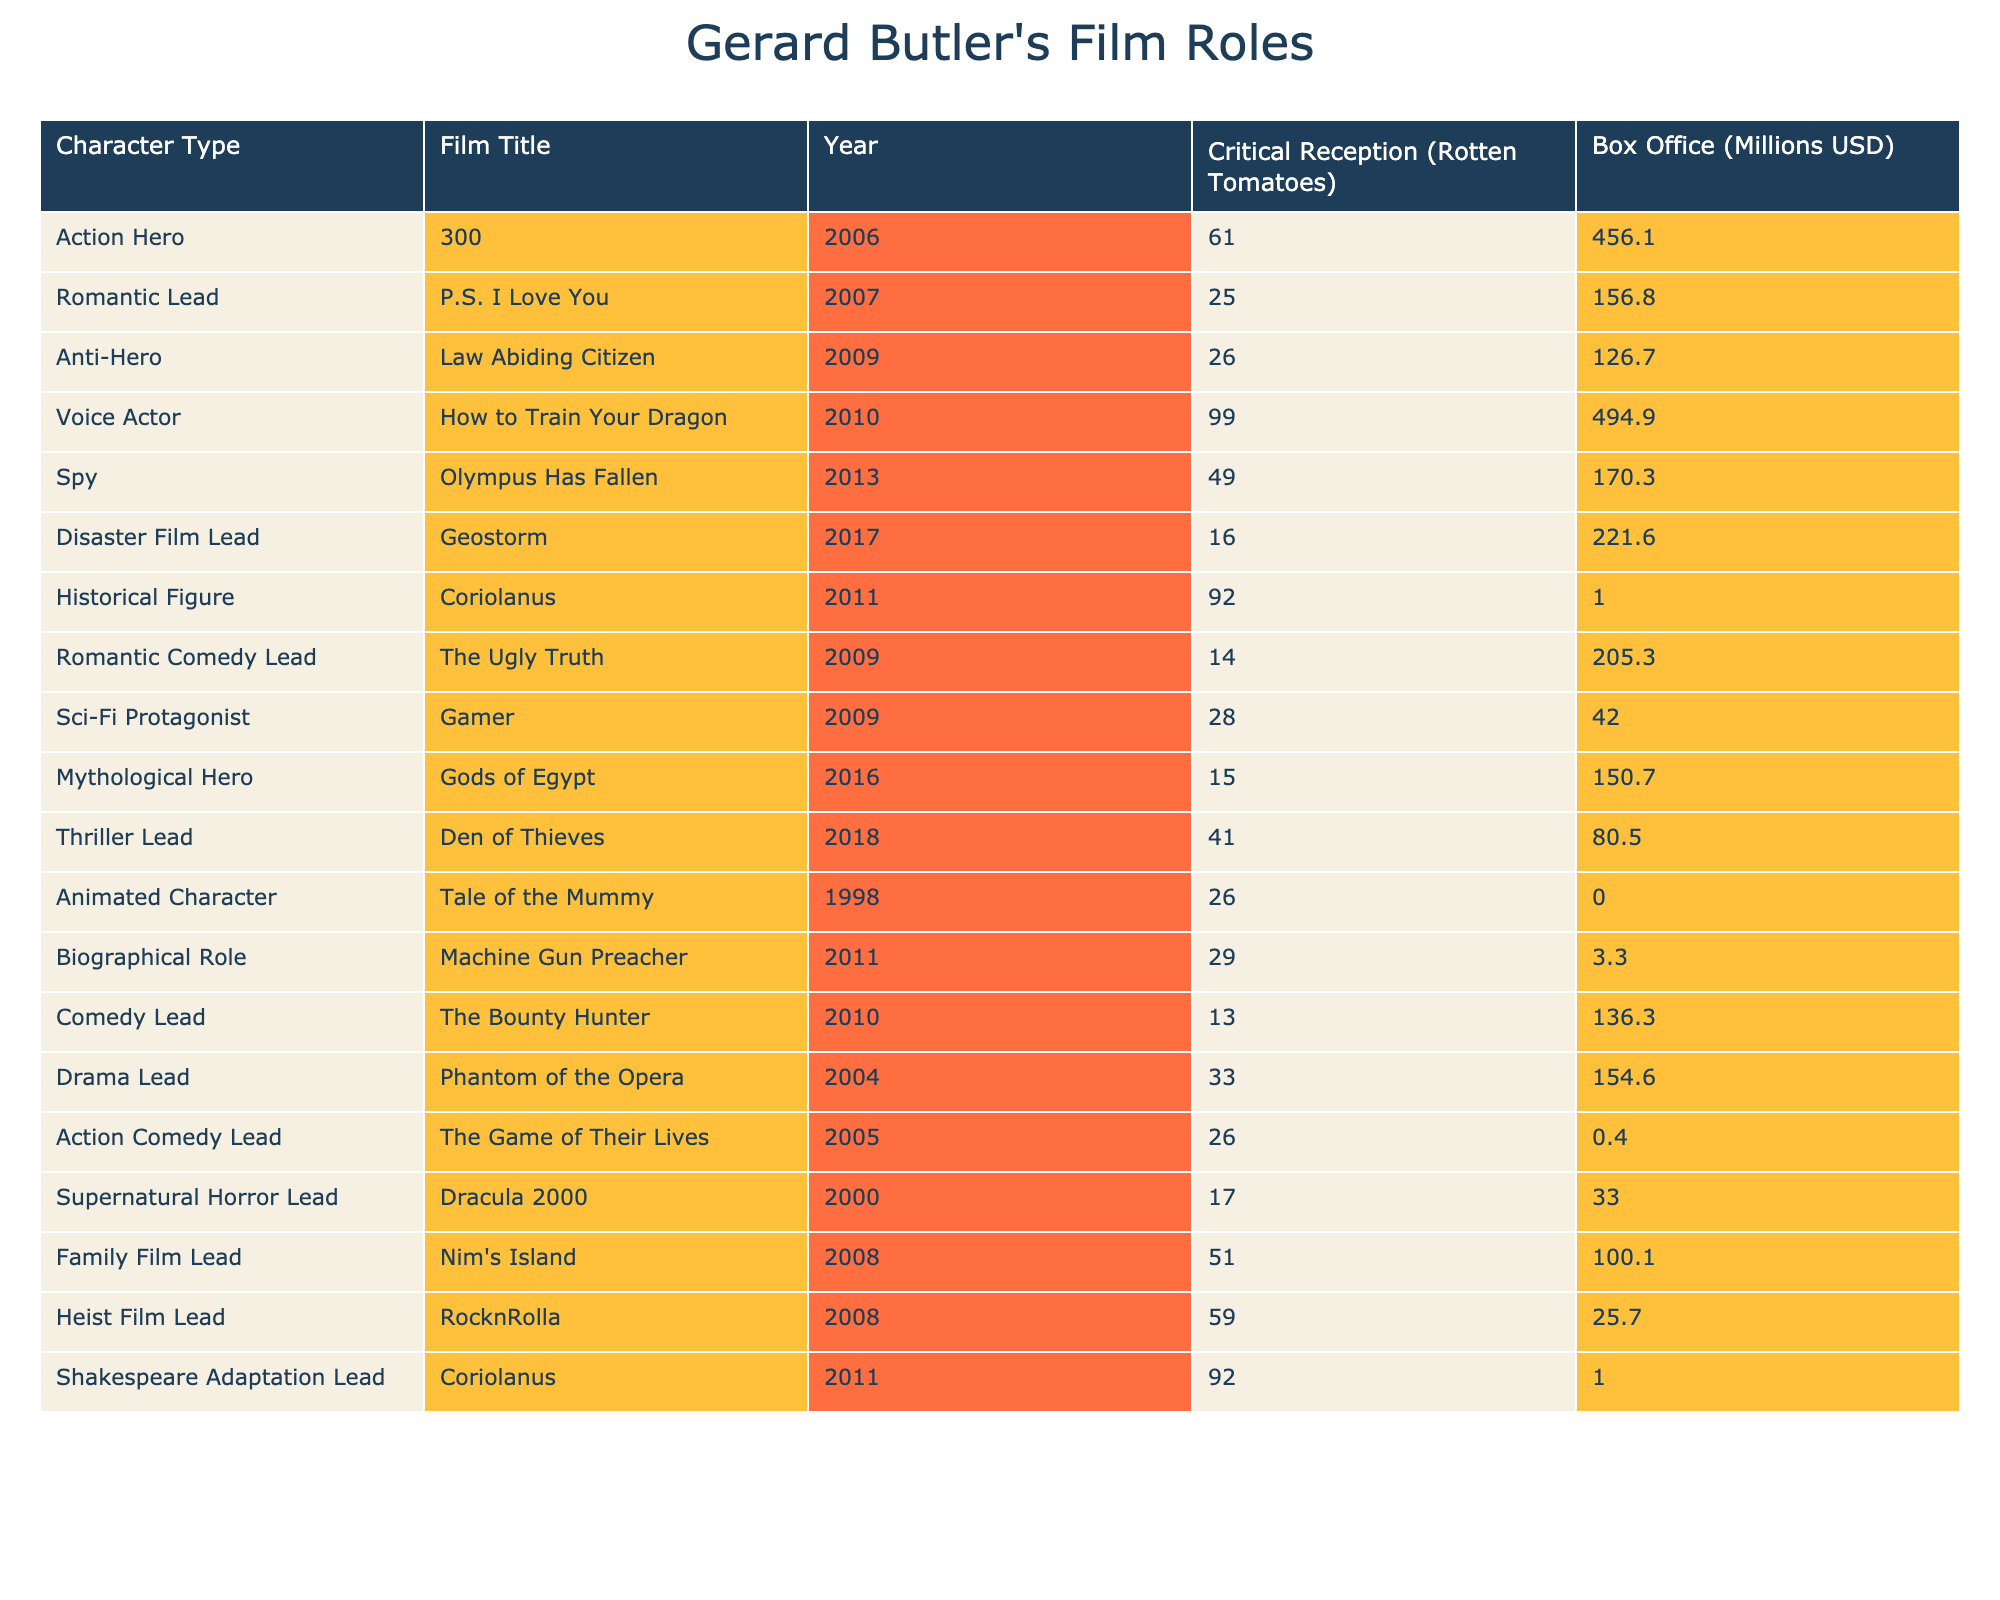What is the film with the highest critical reception among Gerard Butler's roles? Reviewing the table, "How to Train Your Dragon" has a critical reception score of 99%, which is the highest.
Answer: 99% Which film had the lowest box office earnings? Looking at the box office earnings, "Coriolanus" has the lowest earnings listed at 1 million USD.
Answer: 1 million USD What percentage of Gerard Butler's films received a critical reception above 50%? Out of 20 films, 7 films have critical reception scores above 50%: "How to Train Your Dragon," "Coriolanus," "Family Film Lead," "Heist Film Lead," and "300." Therefore, the percentage is (7/20) * 100 = 35%.
Answer: 35% Is "Geostorm" categorized as a disaster film lead? Yes, "Geostorm" is listed under the character type of Disaster Film Lead in the table.
Answer: Yes What is the average box office collection for the Action Hero roles? For the Action Hero role, the only entry is "300" with a box office of 456.1 million USD. Therefore, the average is simply 456.1 million USD.
Answer: 456.1 million USD Which character type is represented the most in the table? After reviewing the table, character types such as Action Hero, Romantic Lead, and Biographical Role are represented only once, while the Animated Character appears just once too, thus there's no dominant character type.
Answer: No dominant type What is the difference between the critical reception of "P.S. I Love You" and "Dracula 2000"? "P.S. I Love You" has a critical reception of 25%, while "Dracula 2000" has 17%. The difference is 25% - 17% = 8%.
Answer: 8% Which film has both a low critical reception and a high box office earnings? "Geostorm" has a critical reception of 16% but box office earnings of 221.6 million USD, making it one of the films that fit this criterion.
Answer: Geostorm What is the total box office earnings of all films categorized as Thrillers? In the table, only "Den of Thieves" is categorized as a Thriller Lead with box office earnings of 80.5 million USD, thus the total is 80.5 million USD.
Answer: 80.5 million USD If Gerard Butler were to act in another animated film, following the success of "How to Train Your Dragon," what critical reception should he aim to match or exceed? He should aim for a score of 99% or higher to match the critical reception of "How to Train Your Dragon."
Answer: 99% 